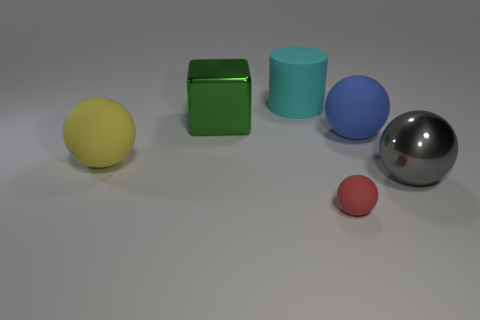Subtract all metallic spheres. How many spheres are left? 3 Add 3 large purple metallic balls. How many objects exist? 9 Subtract all yellow spheres. How many spheres are left? 3 Subtract all large blue rubber objects. Subtract all big green objects. How many objects are left? 4 Add 2 large cubes. How many large cubes are left? 3 Add 3 large cyan things. How many large cyan things exist? 4 Subtract 0 blue blocks. How many objects are left? 6 Subtract all cylinders. How many objects are left? 5 Subtract all cyan spheres. Subtract all green cylinders. How many spheres are left? 4 Subtract all yellow cylinders. How many brown balls are left? 0 